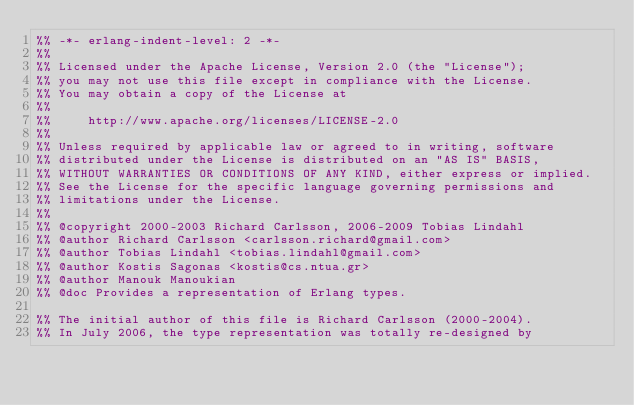Convert code to text. <code><loc_0><loc_0><loc_500><loc_500><_Erlang_>%% -*- erlang-indent-level: 2 -*-
%%
%% Licensed under the Apache License, Version 2.0 (the "License");
%% you may not use this file except in compliance with the License.
%% You may obtain a copy of the License at
%%
%%     http://www.apache.org/licenses/LICENSE-2.0
%%
%% Unless required by applicable law or agreed to in writing, software
%% distributed under the License is distributed on an "AS IS" BASIS,
%% WITHOUT WARRANTIES OR CONDITIONS OF ANY KIND, either express or implied.
%% See the License for the specific language governing permissions and
%% limitations under the License.
%%
%% @copyright 2000-2003 Richard Carlsson, 2006-2009 Tobias Lindahl
%% @author Richard Carlsson <carlsson.richard@gmail.com>
%% @author Tobias Lindahl <tobias.lindahl@gmail.com>
%% @author Kostis Sagonas <kostis@cs.ntua.gr>
%% @author Manouk Manoukian
%% @doc Provides a representation of Erlang types.

%% The initial author of this file is Richard Carlsson (2000-2004).
%% In July 2006, the type representation was totally re-designed by</code> 